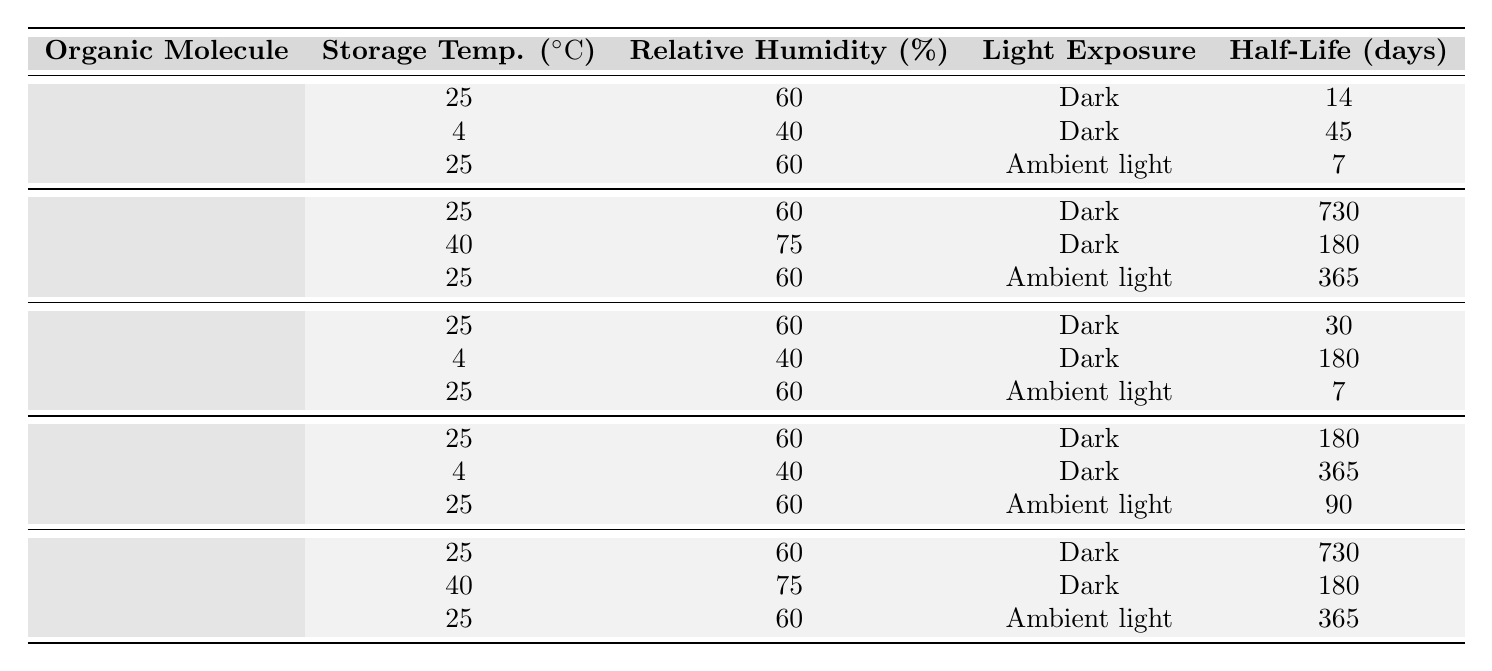What is the half-life of Benzaldehyde when stored at 4°C and 40% relative humidity in the dark? The table shows that for Benzaldehyde at 4°C and 40% relative humidity in the dark, the half-life is 45 days.
Answer: 45 days Which organic molecule has the longest half-life under dark storage at 25°C and 60% relative humidity? According to the table, Acetylsalicylic acid has the longest half-life of 730 days under dark storage at 25°C and 60% relative humidity.
Answer: Acetylsalicylic acid What is the half-life of Diethyl ether under ambient light conditions at 25°C and 60% relative humidity? From the table, the half-life of Diethyl ether under ambient light at 25°C and 60% relative humidity is 90 days.
Answer: 90 days What is the difference in half-life between Acetylsalicylic acid stored in the dark at 40°C and 75% relative humidity and Retinol stored in the dark at 25°C and 60% relative humidity? The half-life of Acetylsalicylic acid at 40°C and 75% is 180 days, and the half-life of Retinol at 25°C and 60% is 30 days. The difference is 180 - 30 = 150 days.
Answer: 150 days Is the half-life of Hydrocortisone less when exposed to ambient light compared to when stored in the dark at 25°C and 60% relative humidity? The half-life of Hydrocortisone in the dark at 25°C and 60% is 730 days, and under ambient light, it is 365 days, so yes, it is less.
Answer: Yes Which organic molecule has the shortest half-life when exposed to ambient light? The table indicates that Benzaldehyde has the shortest half-life of 7 days when exposed to ambient light at 25°C and 60% relative humidity.
Answer: Benzaldehyde What is the average half-life of all the organic molecules stored in dark conditions? Summing the half-lives of all dark storage conditions gives 14 + 45 + 730 + 30 + 180 + 180 + 730 + 365 = 1794 days. There are 8 data points, so the average is 1794/8 = 224.25 days.
Answer: 224.25 days How many organic molecules listed have a half-life of more than 365 days? The table shows that Acetylsalicylic acid and Hydrocortisone, both in dark conditions, have half-lives of 730 days. Therefore, there are 2 molecules with more than 365 days.
Answer: 2 What is the half-life of Benzaldehyde exposed to ambient light compared to Diethyl ether exposed to the same conditions? Benzaldehyde exposed to ambient light has a half-life of 7 days, while Diethyl ether exposed to the same conditions has a half-life of 90 days. 90 - 7 = 83 days difference, indicating Diethyl ether has a longer half-life.
Answer: Diethyl ether has a longer half-life Does Retinol have a longer half-life at 4°C and 40% relative humidity compared to Benzaldehyde under the same conditions? Retinol has a half-life of 180 days at 4°C and 40% relative humidity, while Benzaldehyde has a half-life of 45 days. Since 180 > 45, Retinol indeed has a longer half-life.
Answer: Yes 